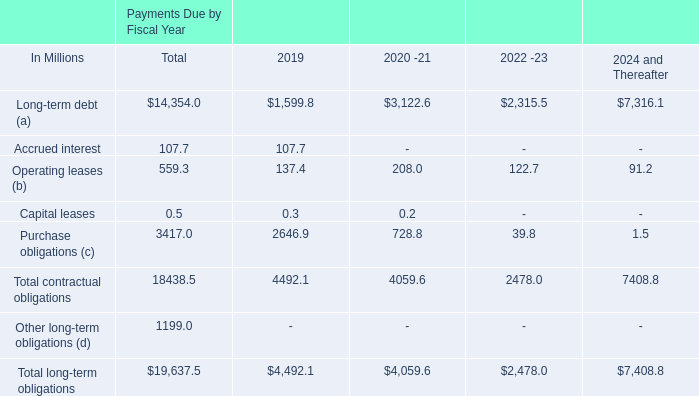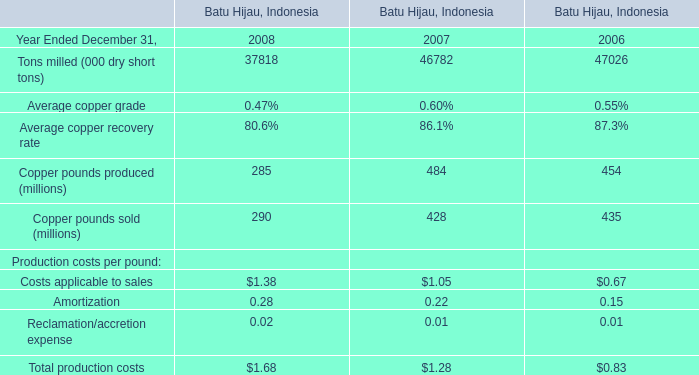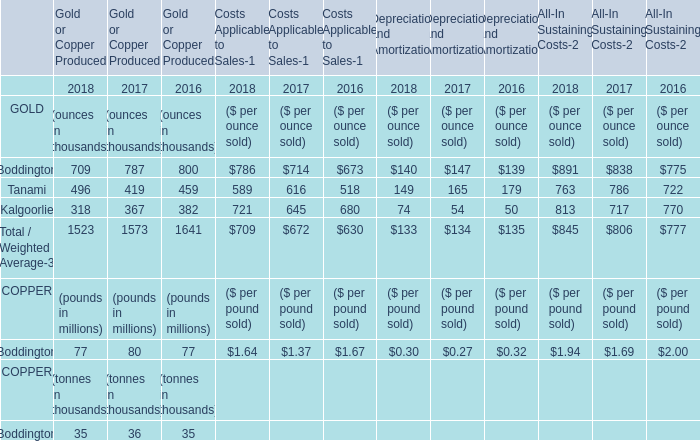Which year is the amount of GOLD in terms of Boddington greater than 789 thousand ounces,for Gold or Copper Produced? 
Answer: 2016. 